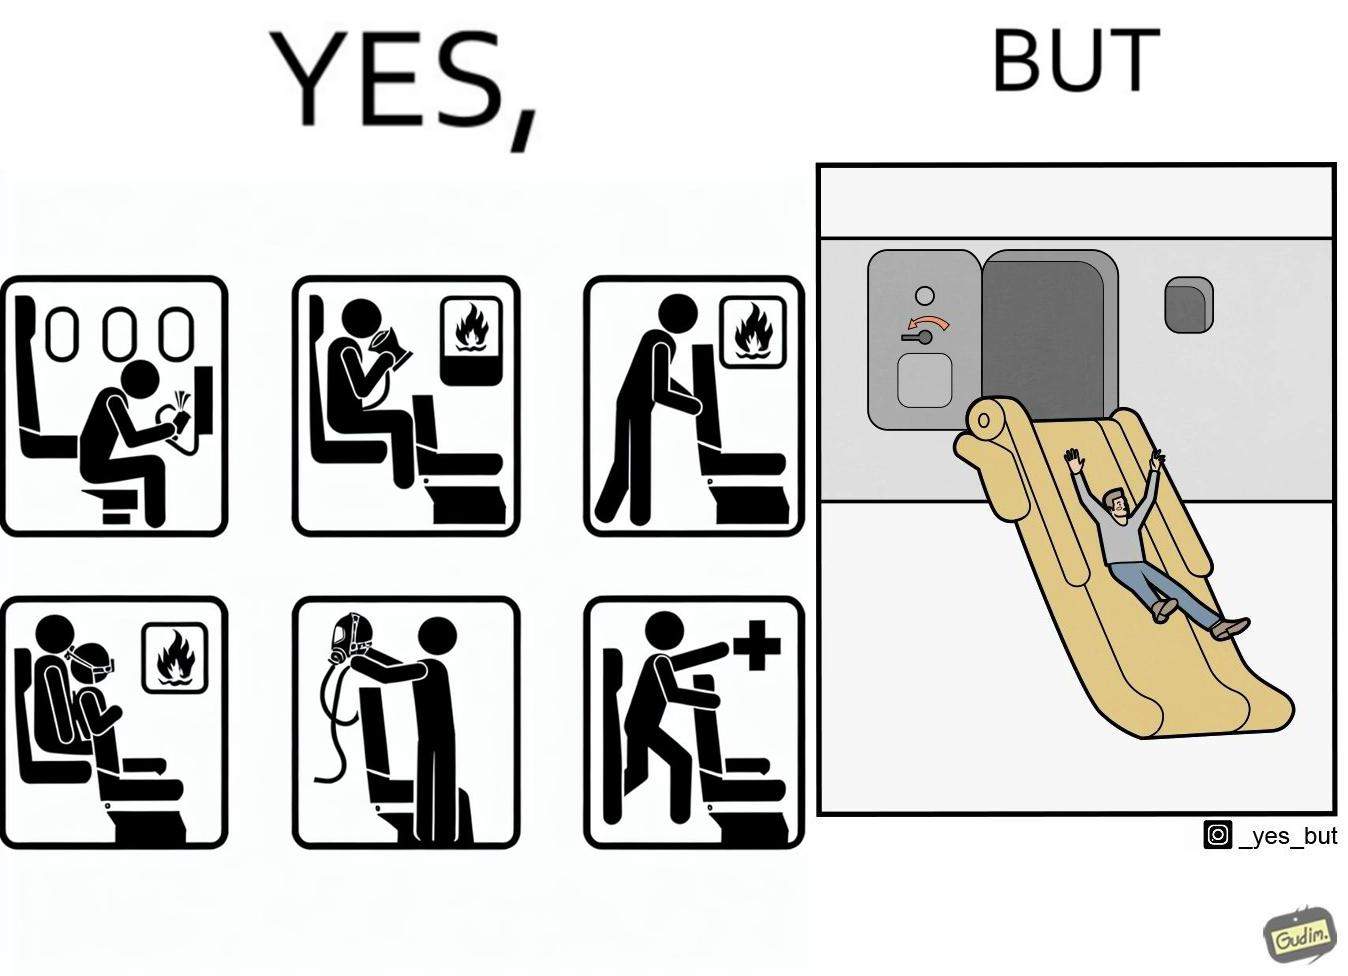Would you classify this image as satirical? Yes, this image is satirical. 